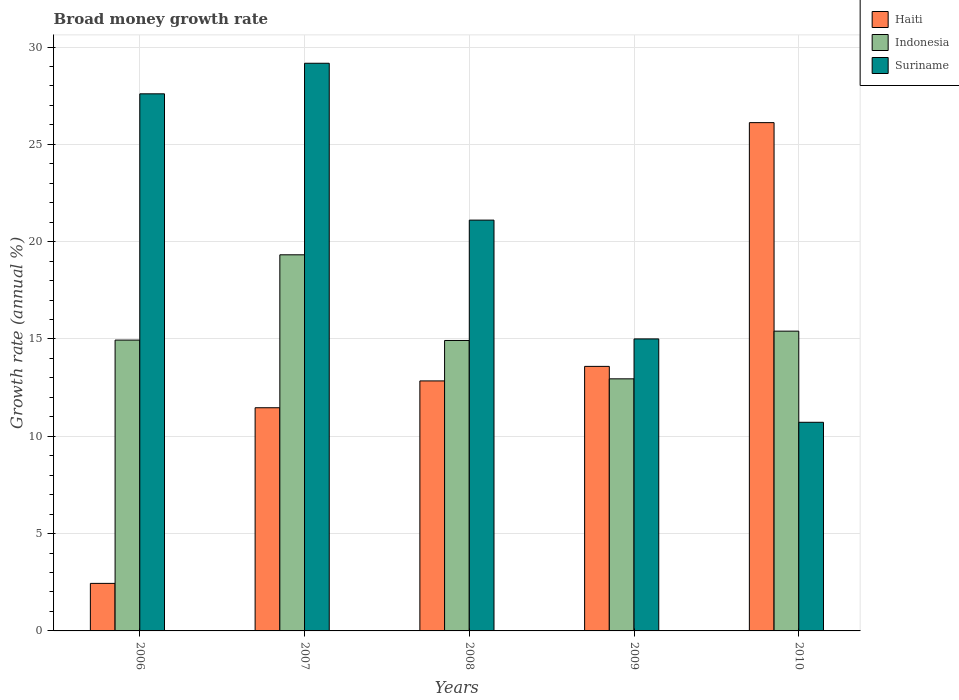How many different coloured bars are there?
Provide a succinct answer. 3. How many groups of bars are there?
Provide a succinct answer. 5. Are the number of bars on each tick of the X-axis equal?
Keep it short and to the point. Yes. In how many cases, is the number of bars for a given year not equal to the number of legend labels?
Offer a very short reply. 0. What is the growth rate in Haiti in 2008?
Offer a terse response. 12.85. Across all years, what is the maximum growth rate in Haiti?
Ensure brevity in your answer.  26.12. Across all years, what is the minimum growth rate in Suriname?
Provide a short and direct response. 10.72. In which year was the growth rate in Suriname maximum?
Your response must be concise. 2007. In which year was the growth rate in Haiti minimum?
Ensure brevity in your answer.  2006. What is the total growth rate in Suriname in the graph?
Make the answer very short. 103.59. What is the difference between the growth rate in Indonesia in 2009 and that in 2010?
Provide a short and direct response. -2.45. What is the difference between the growth rate in Haiti in 2007 and the growth rate in Indonesia in 2008?
Keep it short and to the point. -3.46. What is the average growth rate in Indonesia per year?
Offer a very short reply. 15.51. In the year 2007, what is the difference between the growth rate in Haiti and growth rate in Indonesia?
Your response must be concise. -7.86. In how many years, is the growth rate in Indonesia greater than 24 %?
Your response must be concise. 0. What is the ratio of the growth rate in Indonesia in 2006 to that in 2007?
Offer a terse response. 0.77. What is the difference between the highest and the second highest growth rate in Indonesia?
Keep it short and to the point. 3.92. What is the difference between the highest and the lowest growth rate in Haiti?
Offer a very short reply. 23.67. What does the 2nd bar from the right in 2010 represents?
Ensure brevity in your answer.  Indonesia. Are all the bars in the graph horizontal?
Your response must be concise. No. How many years are there in the graph?
Offer a terse response. 5. Does the graph contain grids?
Give a very brief answer. Yes. Where does the legend appear in the graph?
Offer a terse response. Top right. How many legend labels are there?
Your response must be concise. 3. What is the title of the graph?
Ensure brevity in your answer.  Broad money growth rate. What is the label or title of the Y-axis?
Offer a very short reply. Growth rate (annual %). What is the Growth rate (annual %) of Haiti in 2006?
Offer a terse response. 2.44. What is the Growth rate (annual %) of Indonesia in 2006?
Ensure brevity in your answer.  14.94. What is the Growth rate (annual %) in Suriname in 2006?
Make the answer very short. 27.6. What is the Growth rate (annual %) in Haiti in 2007?
Keep it short and to the point. 11.47. What is the Growth rate (annual %) of Indonesia in 2007?
Offer a very short reply. 19.33. What is the Growth rate (annual %) in Suriname in 2007?
Your answer should be very brief. 29.17. What is the Growth rate (annual %) of Haiti in 2008?
Your answer should be compact. 12.85. What is the Growth rate (annual %) in Indonesia in 2008?
Offer a very short reply. 14.92. What is the Growth rate (annual %) in Suriname in 2008?
Provide a succinct answer. 21.11. What is the Growth rate (annual %) in Haiti in 2009?
Your answer should be compact. 13.59. What is the Growth rate (annual %) in Indonesia in 2009?
Offer a terse response. 12.95. What is the Growth rate (annual %) of Suriname in 2009?
Make the answer very short. 15. What is the Growth rate (annual %) of Haiti in 2010?
Your response must be concise. 26.12. What is the Growth rate (annual %) in Indonesia in 2010?
Your answer should be very brief. 15.4. What is the Growth rate (annual %) of Suriname in 2010?
Your answer should be very brief. 10.72. Across all years, what is the maximum Growth rate (annual %) of Haiti?
Give a very brief answer. 26.12. Across all years, what is the maximum Growth rate (annual %) of Indonesia?
Your response must be concise. 19.33. Across all years, what is the maximum Growth rate (annual %) in Suriname?
Provide a succinct answer. 29.17. Across all years, what is the minimum Growth rate (annual %) in Haiti?
Make the answer very short. 2.44. Across all years, what is the minimum Growth rate (annual %) of Indonesia?
Offer a terse response. 12.95. Across all years, what is the minimum Growth rate (annual %) of Suriname?
Provide a succinct answer. 10.72. What is the total Growth rate (annual %) in Haiti in the graph?
Your answer should be compact. 66.46. What is the total Growth rate (annual %) in Indonesia in the graph?
Give a very brief answer. 77.55. What is the total Growth rate (annual %) of Suriname in the graph?
Offer a terse response. 103.59. What is the difference between the Growth rate (annual %) in Haiti in 2006 and that in 2007?
Your response must be concise. -9.02. What is the difference between the Growth rate (annual %) of Indonesia in 2006 and that in 2007?
Ensure brevity in your answer.  -4.38. What is the difference between the Growth rate (annual %) in Suriname in 2006 and that in 2007?
Your answer should be very brief. -1.57. What is the difference between the Growth rate (annual %) of Haiti in 2006 and that in 2008?
Provide a short and direct response. -10.4. What is the difference between the Growth rate (annual %) in Indonesia in 2006 and that in 2008?
Provide a short and direct response. 0.02. What is the difference between the Growth rate (annual %) in Suriname in 2006 and that in 2008?
Keep it short and to the point. 6.49. What is the difference between the Growth rate (annual %) of Haiti in 2006 and that in 2009?
Offer a very short reply. -11.15. What is the difference between the Growth rate (annual %) of Indonesia in 2006 and that in 2009?
Keep it short and to the point. 1.99. What is the difference between the Growth rate (annual %) in Suriname in 2006 and that in 2009?
Your response must be concise. 12.59. What is the difference between the Growth rate (annual %) in Haiti in 2006 and that in 2010?
Your answer should be very brief. -23.67. What is the difference between the Growth rate (annual %) in Indonesia in 2006 and that in 2010?
Keep it short and to the point. -0.46. What is the difference between the Growth rate (annual %) of Suriname in 2006 and that in 2010?
Keep it short and to the point. 16.88. What is the difference between the Growth rate (annual %) in Haiti in 2007 and that in 2008?
Ensure brevity in your answer.  -1.38. What is the difference between the Growth rate (annual %) in Indonesia in 2007 and that in 2008?
Keep it short and to the point. 4.4. What is the difference between the Growth rate (annual %) in Suriname in 2007 and that in 2008?
Offer a very short reply. 8.06. What is the difference between the Growth rate (annual %) in Haiti in 2007 and that in 2009?
Your answer should be very brief. -2.12. What is the difference between the Growth rate (annual %) in Indonesia in 2007 and that in 2009?
Offer a terse response. 6.37. What is the difference between the Growth rate (annual %) in Suriname in 2007 and that in 2009?
Keep it short and to the point. 14.16. What is the difference between the Growth rate (annual %) in Haiti in 2007 and that in 2010?
Your answer should be compact. -14.65. What is the difference between the Growth rate (annual %) in Indonesia in 2007 and that in 2010?
Give a very brief answer. 3.92. What is the difference between the Growth rate (annual %) of Suriname in 2007 and that in 2010?
Your answer should be very brief. 18.45. What is the difference between the Growth rate (annual %) of Haiti in 2008 and that in 2009?
Provide a succinct answer. -0.75. What is the difference between the Growth rate (annual %) of Indonesia in 2008 and that in 2009?
Provide a short and direct response. 1.97. What is the difference between the Growth rate (annual %) in Suriname in 2008 and that in 2009?
Ensure brevity in your answer.  6.1. What is the difference between the Growth rate (annual %) of Haiti in 2008 and that in 2010?
Provide a short and direct response. -13.27. What is the difference between the Growth rate (annual %) in Indonesia in 2008 and that in 2010?
Ensure brevity in your answer.  -0.48. What is the difference between the Growth rate (annual %) in Suriname in 2008 and that in 2010?
Provide a succinct answer. 10.39. What is the difference between the Growth rate (annual %) in Haiti in 2009 and that in 2010?
Offer a terse response. -12.52. What is the difference between the Growth rate (annual %) of Indonesia in 2009 and that in 2010?
Give a very brief answer. -2.45. What is the difference between the Growth rate (annual %) in Suriname in 2009 and that in 2010?
Give a very brief answer. 4.28. What is the difference between the Growth rate (annual %) of Haiti in 2006 and the Growth rate (annual %) of Indonesia in 2007?
Your answer should be compact. -16.88. What is the difference between the Growth rate (annual %) in Haiti in 2006 and the Growth rate (annual %) in Suriname in 2007?
Give a very brief answer. -26.72. What is the difference between the Growth rate (annual %) in Indonesia in 2006 and the Growth rate (annual %) in Suriname in 2007?
Offer a very short reply. -14.22. What is the difference between the Growth rate (annual %) in Haiti in 2006 and the Growth rate (annual %) in Indonesia in 2008?
Offer a terse response. -12.48. What is the difference between the Growth rate (annual %) in Haiti in 2006 and the Growth rate (annual %) in Suriname in 2008?
Provide a succinct answer. -18.66. What is the difference between the Growth rate (annual %) in Indonesia in 2006 and the Growth rate (annual %) in Suriname in 2008?
Offer a terse response. -6.16. What is the difference between the Growth rate (annual %) in Haiti in 2006 and the Growth rate (annual %) in Indonesia in 2009?
Offer a very short reply. -10.51. What is the difference between the Growth rate (annual %) of Haiti in 2006 and the Growth rate (annual %) of Suriname in 2009?
Make the answer very short. -12.56. What is the difference between the Growth rate (annual %) in Indonesia in 2006 and the Growth rate (annual %) in Suriname in 2009?
Your response must be concise. -0.06. What is the difference between the Growth rate (annual %) in Haiti in 2006 and the Growth rate (annual %) in Indonesia in 2010?
Make the answer very short. -12.96. What is the difference between the Growth rate (annual %) in Haiti in 2006 and the Growth rate (annual %) in Suriname in 2010?
Offer a very short reply. -8.28. What is the difference between the Growth rate (annual %) in Indonesia in 2006 and the Growth rate (annual %) in Suriname in 2010?
Offer a terse response. 4.22. What is the difference between the Growth rate (annual %) of Haiti in 2007 and the Growth rate (annual %) of Indonesia in 2008?
Provide a succinct answer. -3.46. What is the difference between the Growth rate (annual %) of Haiti in 2007 and the Growth rate (annual %) of Suriname in 2008?
Offer a terse response. -9.64. What is the difference between the Growth rate (annual %) of Indonesia in 2007 and the Growth rate (annual %) of Suriname in 2008?
Provide a short and direct response. -1.78. What is the difference between the Growth rate (annual %) of Haiti in 2007 and the Growth rate (annual %) of Indonesia in 2009?
Your answer should be very brief. -1.48. What is the difference between the Growth rate (annual %) in Haiti in 2007 and the Growth rate (annual %) in Suriname in 2009?
Offer a terse response. -3.54. What is the difference between the Growth rate (annual %) of Indonesia in 2007 and the Growth rate (annual %) of Suriname in 2009?
Your answer should be compact. 4.32. What is the difference between the Growth rate (annual %) of Haiti in 2007 and the Growth rate (annual %) of Indonesia in 2010?
Keep it short and to the point. -3.94. What is the difference between the Growth rate (annual %) of Haiti in 2007 and the Growth rate (annual %) of Suriname in 2010?
Offer a terse response. 0.75. What is the difference between the Growth rate (annual %) in Indonesia in 2007 and the Growth rate (annual %) in Suriname in 2010?
Offer a terse response. 8.61. What is the difference between the Growth rate (annual %) in Haiti in 2008 and the Growth rate (annual %) in Indonesia in 2009?
Your answer should be very brief. -0.11. What is the difference between the Growth rate (annual %) of Haiti in 2008 and the Growth rate (annual %) of Suriname in 2009?
Provide a short and direct response. -2.16. What is the difference between the Growth rate (annual %) of Indonesia in 2008 and the Growth rate (annual %) of Suriname in 2009?
Offer a terse response. -0.08. What is the difference between the Growth rate (annual %) in Haiti in 2008 and the Growth rate (annual %) in Indonesia in 2010?
Ensure brevity in your answer.  -2.56. What is the difference between the Growth rate (annual %) of Haiti in 2008 and the Growth rate (annual %) of Suriname in 2010?
Provide a short and direct response. 2.13. What is the difference between the Growth rate (annual %) of Indonesia in 2008 and the Growth rate (annual %) of Suriname in 2010?
Your response must be concise. 4.2. What is the difference between the Growth rate (annual %) in Haiti in 2009 and the Growth rate (annual %) in Indonesia in 2010?
Provide a short and direct response. -1.81. What is the difference between the Growth rate (annual %) in Haiti in 2009 and the Growth rate (annual %) in Suriname in 2010?
Keep it short and to the point. 2.87. What is the difference between the Growth rate (annual %) of Indonesia in 2009 and the Growth rate (annual %) of Suriname in 2010?
Provide a short and direct response. 2.23. What is the average Growth rate (annual %) of Haiti per year?
Keep it short and to the point. 13.29. What is the average Growth rate (annual %) in Indonesia per year?
Make the answer very short. 15.51. What is the average Growth rate (annual %) of Suriname per year?
Give a very brief answer. 20.72. In the year 2006, what is the difference between the Growth rate (annual %) of Haiti and Growth rate (annual %) of Indonesia?
Provide a succinct answer. -12.5. In the year 2006, what is the difference between the Growth rate (annual %) of Haiti and Growth rate (annual %) of Suriname?
Your answer should be compact. -25.15. In the year 2006, what is the difference between the Growth rate (annual %) in Indonesia and Growth rate (annual %) in Suriname?
Provide a succinct answer. -12.65. In the year 2007, what is the difference between the Growth rate (annual %) in Haiti and Growth rate (annual %) in Indonesia?
Make the answer very short. -7.86. In the year 2007, what is the difference between the Growth rate (annual %) in Haiti and Growth rate (annual %) in Suriname?
Provide a succinct answer. -17.7. In the year 2007, what is the difference between the Growth rate (annual %) in Indonesia and Growth rate (annual %) in Suriname?
Your answer should be compact. -9.84. In the year 2008, what is the difference between the Growth rate (annual %) of Haiti and Growth rate (annual %) of Indonesia?
Your answer should be very brief. -2.08. In the year 2008, what is the difference between the Growth rate (annual %) of Haiti and Growth rate (annual %) of Suriname?
Give a very brief answer. -8.26. In the year 2008, what is the difference between the Growth rate (annual %) of Indonesia and Growth rate (annual %) of Suriname?
Give a very brief answer. -6.18. In the year 2009, what is the difference between the Growth rate (annual %) of Haiti and Growth rate (annual %) of Indonesia?
Your answer should be compact. 0.64. In the year 2009, what is the difference between the Growth rate (annual %) in Haiti and Growth rate (annual %) in Suriname?
Provide a short and direct response. -1.41. In the year 2009, what is the difference between the Growth rate (annual %) in Indonesia and Growth rate (annual %) in Suriname?
Ensure brevity in your answer.  -2.05. In the year 2010, what is the difference between the Growth rate (annual %) of Haiti and Growth rate (annual %) of Indonesia?
Your answer should be compact. 10.71. In the year 2010, what is the difference between the Growth rate (annual %) of Haiti and Growth rate (annual %) of Suriname?
Give a very brief answer. 15.4. In the year 2010, what is the difference between the Growth rate (annual %) of Indonesia and Growth rate (annual %) of Suriname?
Offer a very short reply. 4.68. What is the ratio of the Growth rate (annual %) in Haiti in 2006 to that in 2007?
Your answer should be very brief. 0.21. What is the ratio of the Growth rate (annual %) of Indonesia in 2006 to that in 2007?
Give a very brief answer. 0.77. What is the ratio of the Growth rate (annual %) in Suriname in 2006 to that in 2007?
Provide a succinct answer. 0.95. What is the ratio of the Growth rate (annual %) of Haiti in 2006 to that in 2008?
Give a very brief answer. 0.19. What is the ratio of the Growth rate (annual %) of Indonesia in 2006 to that in 2008?
Offer a terse response. 1. What is the ratio of the Growth rate (annual %) in Suriname in 2006 to that in 2008?
Your answer should be very brief. 1.31. What is the ratio of the Growth rate (annual %) of Haiti in 2006 to that in 2009?
Keep it short and to the point. 0.18. What is the ratio of the Growth rate (annual %) of Indonesia in 2006 to that in 2009?
Your response must be concise. 1.15. What is the ratio of the Growth rate (annual %) in Suriname in 2006 to that in 2009?
Your answer should be compact. 1.84. What is the ratio of the Growth rate (annual %) of Haiti in 2006 to that in 2010?
Provide a succinct answer. 0.09. What is the ratio of the Growth rate (annual %) in Indonesia in 2006 to that in 2010?
Your answer should be compact. 0.97. What is the ratio of the Growth rate (annual %) of Suriname in 2006 to that in 2010?
Give a very brief answer. 2.57. What is the ratio of the Growth rate (annual %) in Haiti in 2007 to that in 2008?
Your answer should be very brief. 0.89. What is the ratio of the Growth rate (annual %) in Indonesia in 2007 to that in 2008?
Provide a succinct answer. 1.29. What is the ratio of the Growth rate (annual %) of Suriname in 2007 to that in 2008?
Give a very brief answer. 1.38. What is the ratio of the Growth rate (annual %) of Haiti in 2007 to that in 2009?
Ensure brevity in your answer.  0.84. What is the ratio of the Growth rate (annual %) of Indonesia in 2007 to that in 2009?
Provide a succinct answer. 1.49. What is the ratio of the Growth rate (annual %) in Suriname in 2007 to that in 2009?
Give a very brief answer. 1.94. What is the ratio of the Growth rate (annual %) in Haiti in 2007 to that in 2010?
Ensure brevity in your answer.  0.44. What is the ratio of the Growth rate (annual %) in Indonesia in 2007 to that in 2010?
Give a very brief answer. 1.25. What is the ratio of the Growth rate (annual %) in Suriname in 2007 to that in 2010?
Make the answer very short. 2.72. What is the ratio of the Growth rate (annual %) of Haiti in 2008 to that in 2009?
Make the answer very short. 0.94. What is the ratio of the Growth rate (annual %) in Indonesia in 2008 to that in 2009?
Provide a short and direct response. 1.15. What is the ratio of the Growth rate (annual %) in Suriname in 2008 to that in 2009?
Ensure brevity in your answer.  1.41. What is the ratio of the Growth rate (annual %) in Haiti in 2008 to that in 2010?
Your response must be concise. 0.49. What is the ratio of the Growth rate (annual %) of Indonesia in 2008 to that in 2010?
Make the answer very short. 0.97. What is the ratio of the Growth rate (annual %) in Suriname in 2008 to that in 2010?
Your answer should be very brief. 1.97. What is the ratio of the Growth rate (annual %) of Haiti in 2009 to that in 2010?
Provide a succinct answer. 0.52. What is the ratio of the Growth rate (annual %) in Indonesia in 2009 to that in 2010?
Offer a terse response. 0.84. What is the ratio of the Growth rate (annual %) in Suriname in 2009 to that in 2010?
Your answer should be compact. 1.4. What is the difference between the highest and the second highest Growth rate (annual %) in Haiti?
Ensure brevity in your answer.  12.52. What is the difference between the highest and the second highest Growth rate (annual %) of Indonesia?
Your answer should be very brief. 3.92. What is the difference between the highest and the second highest Growth rate (annual %) in Suriname?
Make the answer very short. 1.57. What is the difference between the highest and the lowest Growth rate (annual %) of Haiti?
Provide a succinct answer. 23.67. What is the difference between the highest and the lowest Growth rate (annual %) in Indonesia?
Ensure brevity in your answer.  6.37. What is the difference between the highest and the lowest Growth rate (annual %) in Suriname?
Your response must be concise. 18.45. 